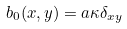<formula> <loc_0><loc_0><loc_500><loc_500>b _ { 0 } ( x , y ) = a \kappa \delta _ { x y }</formula> 